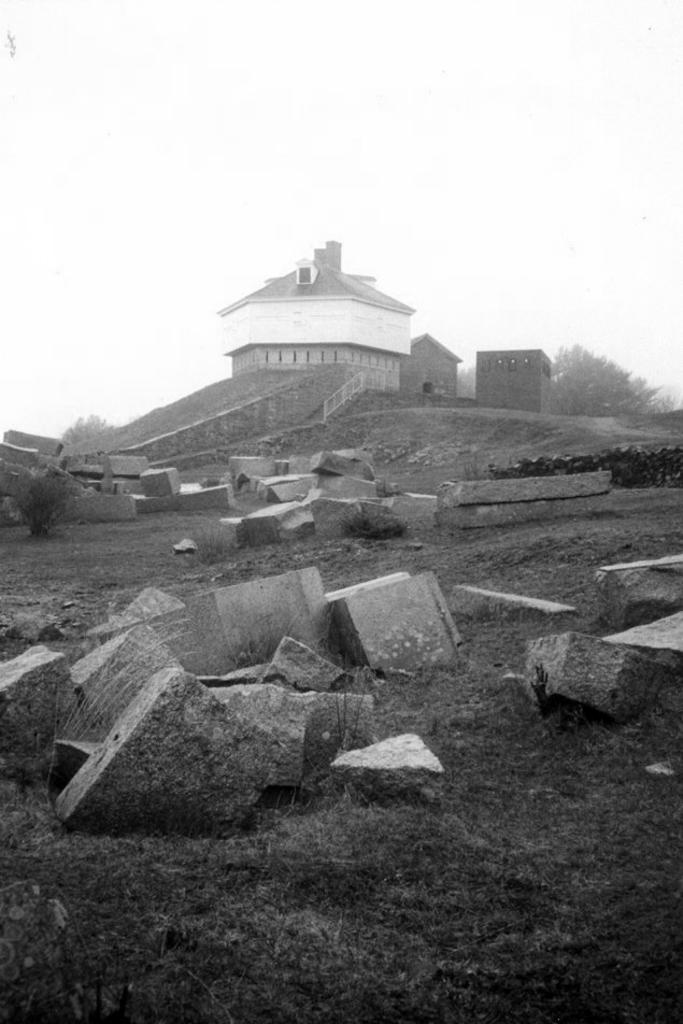What type of vegetation can be seen in the image? There are plants and grass in the image. What is on the ground in the image? There are stones on the ground in the image. What type of structures are visible in the image? There are houses in the image. What else can be seen in the image besides plants, grass, stones, and houses? There are other objects in the image. What is visible in the background of the image? The sky is visible in the image. What type of jar is being used to store the mind in the image? There is no jar or mention of a mind in the image; it features plants, grass, stones, houses, and other objects. Can you tell me the name of the partner who is present in the image? There is no partner or person present in the image; it only features objects and structures. 